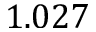<formula> <loc_0><loc_0><loc_500><loc_500>1 . 0 2 7</formula> 